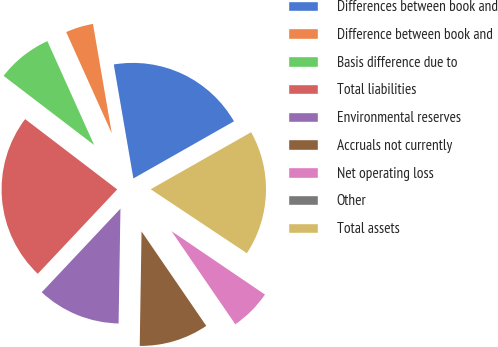Convert chart. <chart><loc_0><loc_0><loc_500><loc_500><pie_chart><fcel>Differences between book and<fcel>Difference between book and<fcel>Basis difference due to<fcel>Total liabilities<fcel>Environmental reserves<fcel>Accruals not currently<fcel>Net operating loss<fcel>Other<fcel>Total assets<nl><fcel>19.49%<fcel>4.02%<fcel>7.89%<fcel>23.36%<fcel>11.76%<fcel>9.82%<fcel>5.95%<fcel>0.15%<fcel>17.56%<nl></chart> 